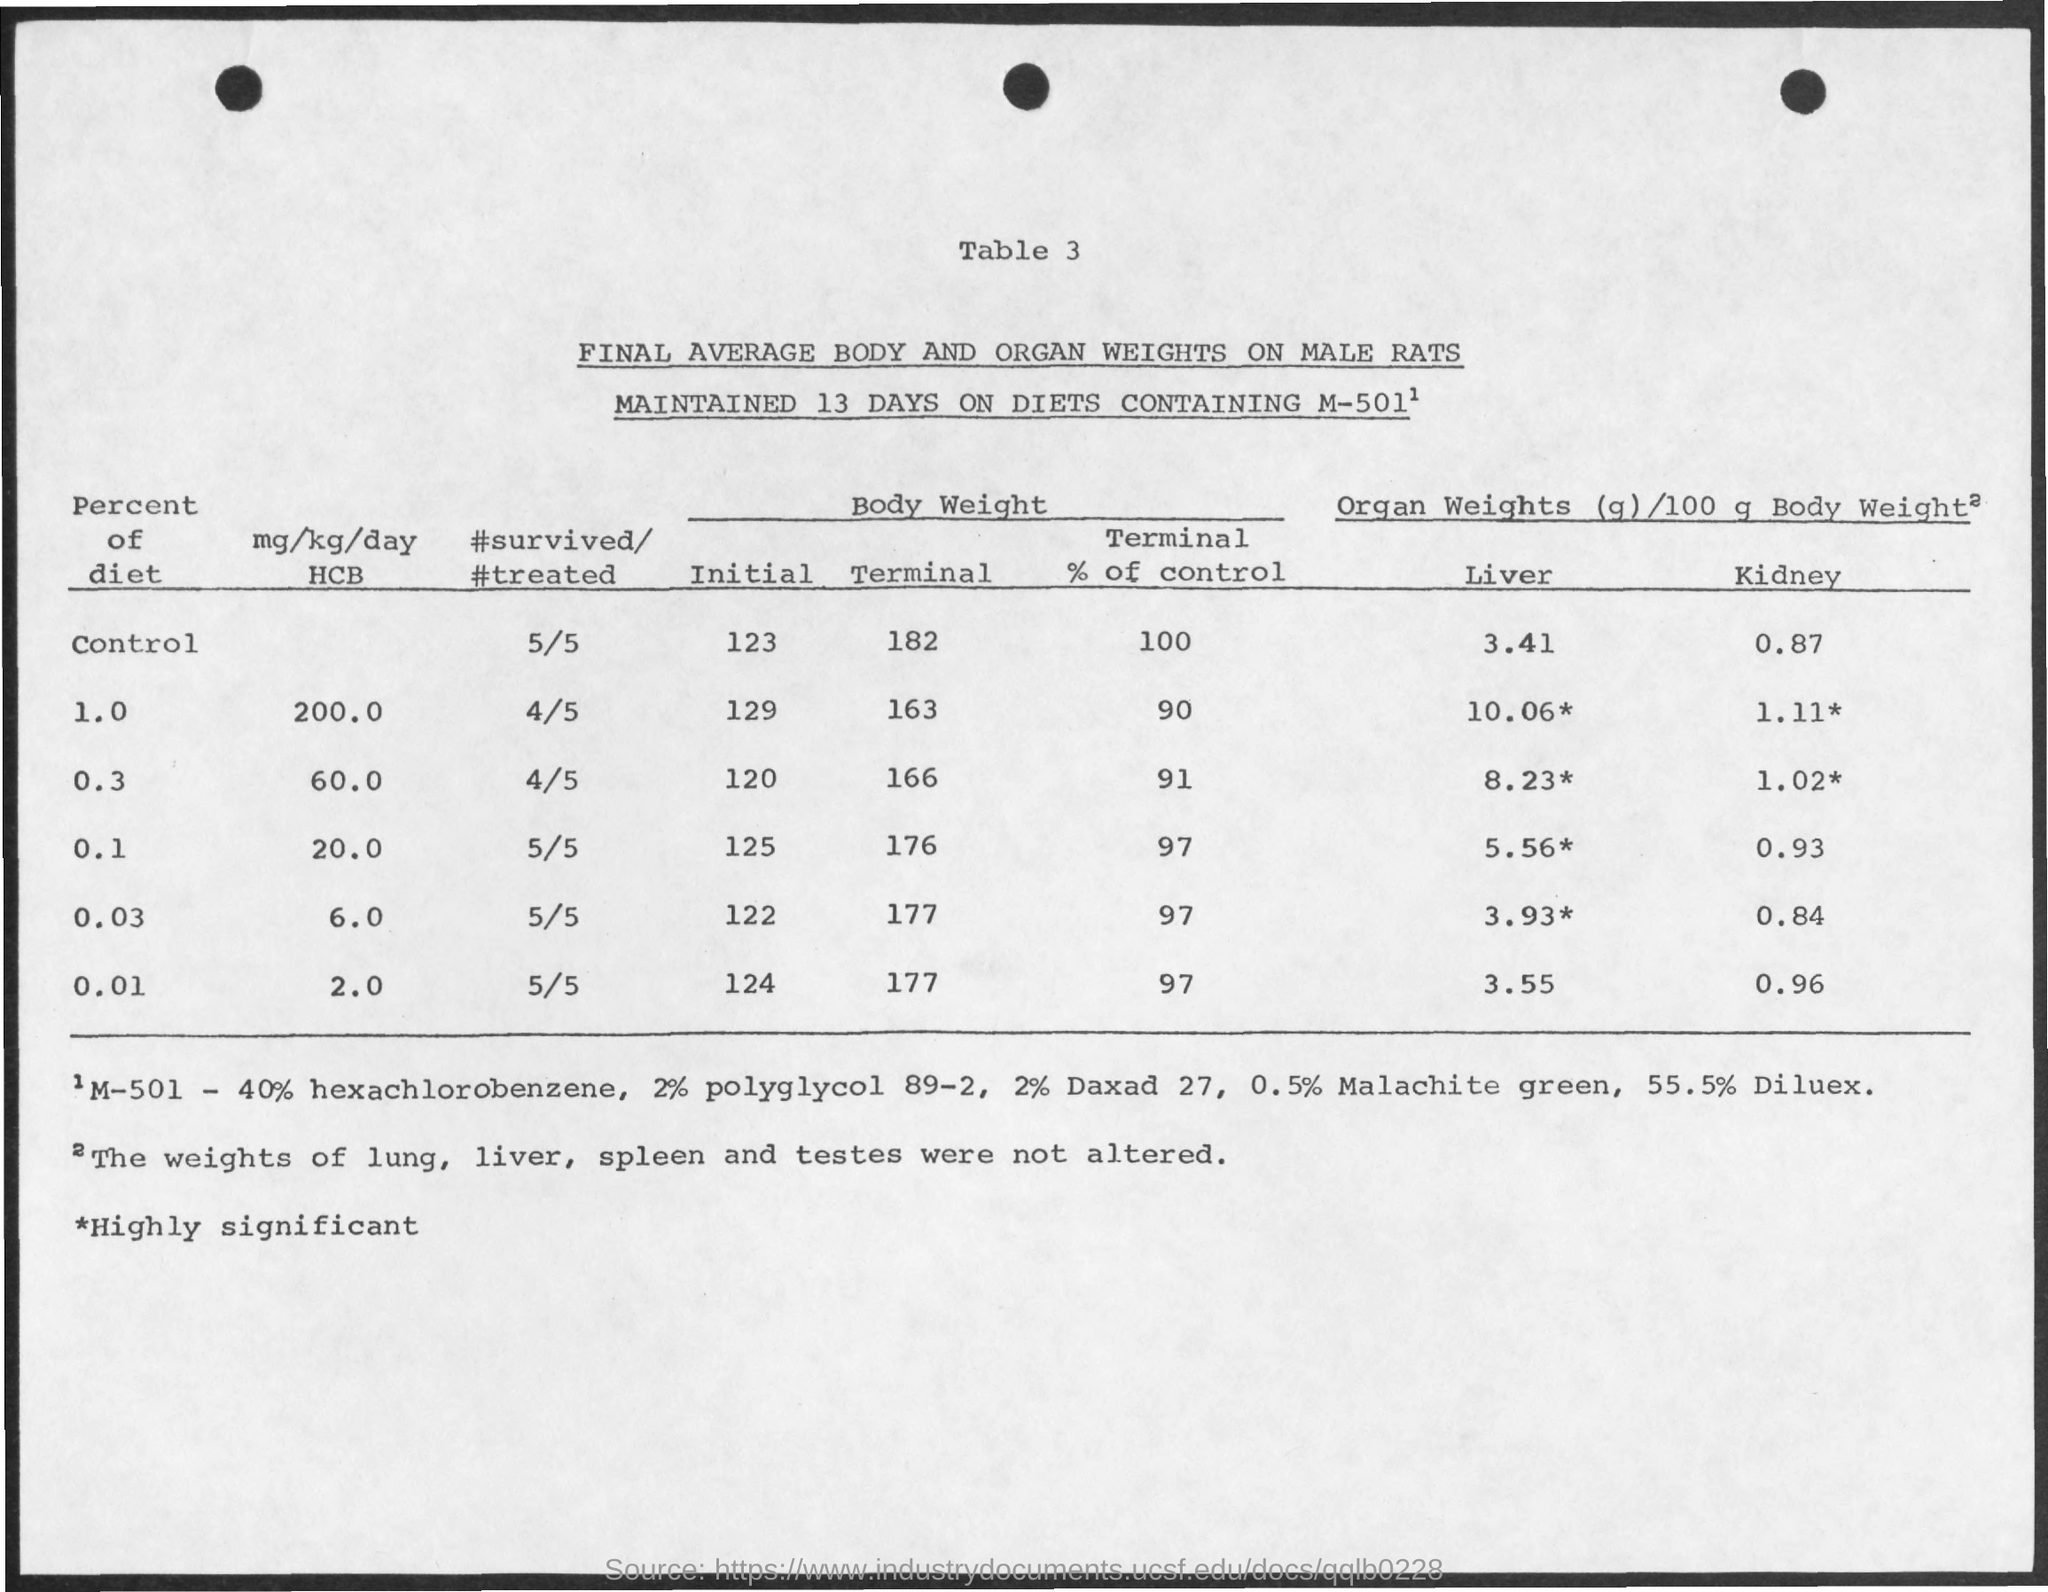Draw attention to some important aspects in this diagram. Please provide the table number, specifically 'table 3.' 